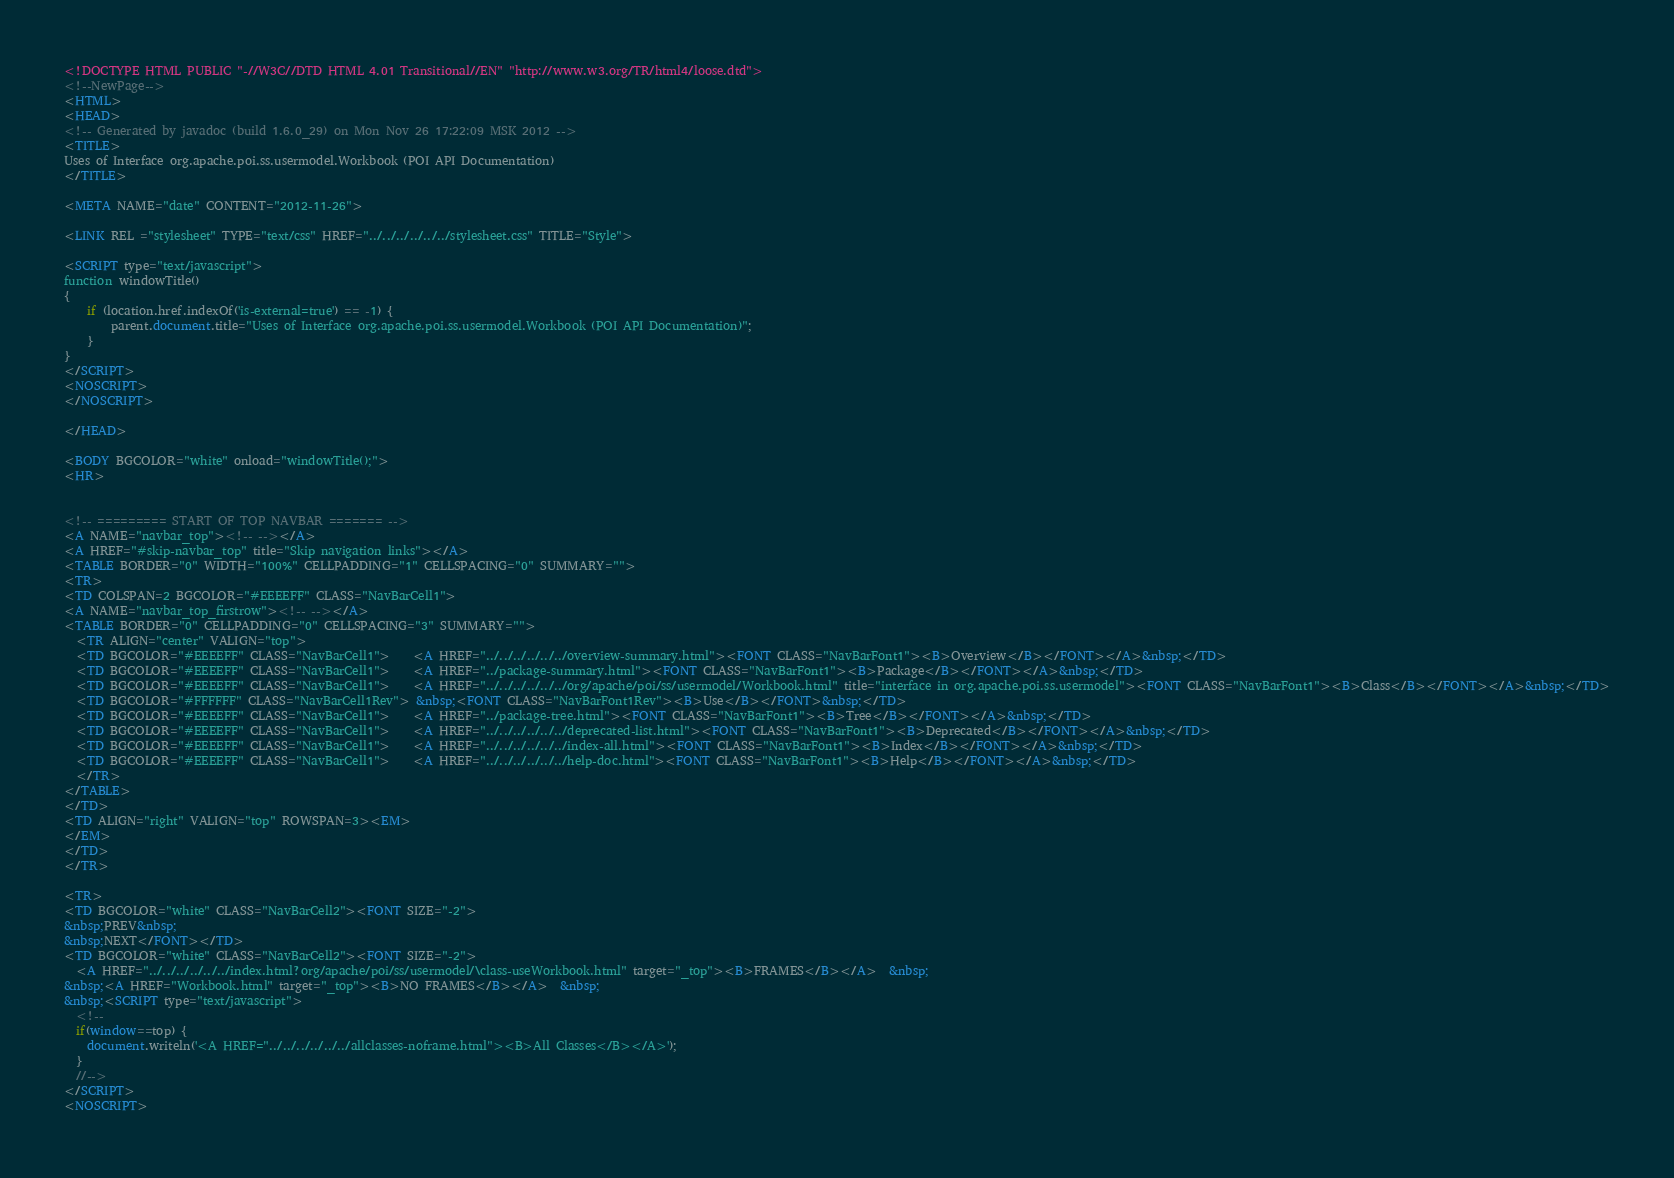Convert code to text. <code><loc_0><loc_0><loc_500><loc_500><_HTML_><!DOCTYPE HTML PUBLIC "-//W3C//DTD HTML 4.01 Transitional//EN" "http://www.w3.org/TR/html4/loose.dtd">
<!--NewPage-->
<HTML>
<HEAD>
<!-- Generated by javadoc (build 1.6.0_29) on Mon Nov 26 17:22:09 MSK 2012 -->
<TITLE>
Uses of Interface org.apache.poi.ss.usermodel.Workbook (POI API Documentation)
</TITLE>

<META NAME="date" CONTENT="2012-11-26">

<LINK REL ="stylesheet" TYPE="text/css" HREF="../../../../../../stylesheet.css" TITLE="Style">

<SCRIPT type="text/javascript">
function windowTitle()
{
    if (location.href.indexOf('is-external=true') == -1) {
        parent.document.title="Uses of Interface org.apache.poi.ss.usermodel.Workbook (POI API Documentation)";
    }
}
</SCRIPT>
<NOSCRIPT>
</NOSCRIPT>

</HEAD>

<BODY BGCOLOR="white" onload="windowTitle();">
<HR>


<!-- ========= START OF TOP NAVBAR ======= -->
<A NAME="navbar_top"><!-- --></A>
<A HREF="#skip-navbar_top" title="Skip navigation links"></A>
<TABLE BORDER="0" WIDTH="100%" CELLPADDING="1" CELLSPACING="0" SUMMARY="">
<TR>
<TD COLSPAN=2 BGCOLOR="#EEEEFF" CLASS="NavBarCell1">
<A NAME="navbar_top_firstrow"><!-- --></A>
<TABLE BORDER="0" CELLPADDING="0" CELLSPACING="3" SUMMARY="">
  <TR ALIGN="center" VALIGN="top">
  <TD BGCOLOR="#EEEEFF" CLASS="NavBarCell1">    <A HREF="../../../../../../overview-summary.html"><FONT CLASS="NavBarFont1"><B>Overview</B></FONT></A>&nbsp;</TD>
  <TD BGCOLOR="#EEEEFF" CLASS="NavBarCell1">    <A HREF="../package-summary.html"><FONT CLASS="NavBarFont1"><B>Package</B></FONT></A>&nbsp;</TD>
  <TD BGCOLOR="#EEEEFF" CLASS="NavBarCell1">    <A HREF="../../../../../../org/apache/poi/ss/usermodel/Workbook.html" title="interface in org.apache.poi.ss.usermodel"><FONT CLASS="NavBarFont1"><B>Class</B></FONT></A>&nbsp;</TD>
  <TD BGCOLOR="#FFFFFF" CLASS="NavBarCell1Rev"> &nbsp;<FONT CLASS="NavBarFont1Rev"><B>Use</B></FONT>&nbsp;</TD>
  <TD BGCOLOR="#EEEEFF" CLASS="NavBarCell1">    <A HREF="../package-tree.html"><FONT CLASS="NavBarFont1"><B>Tree</B></FONT></A>&nbsp;</TD>
  <TD BGCOLOR="#EEEEFF" CLASS="NavBarCell1">    <A HREF="../../../../../../deprecated-list.html"><FONT CLASS="NavBarFont1"><B>Deprecated</B></FONT></A>&nbsp;</TD>
  <TD BGCOLOR="#EEEEFF" CLASS="NavBarCell1">    <A HREF="../../../../../../index-all.html"><FONT CLASS="NavBarFont1"><B>Index</B></FONT></A>&nbsp;</TD>
  <TD BGCOLOR="#EEEEFF" CLASS="NavBarCell1">    <A HREF="../../../../../../help-doc.html"><FONT CLASS="NavBarFont1"><B>Help</B></FONT></A>&nbsp;</TD>
  </TR>
</TABLE>
</TD>
<TD ALIGN="right" VALIGN="top" ROWSPAN=3><EM>
</EM>
</TD>
</TR>

<TR>
<TD BGCOLOR="white" CLASS="NavBarCell2"><FONT SIZE="-2">
&nbsp;PREV&nbsp;
&nbsp;NEXT</FONT></TD>
<TD BGCOLOR="white" CLASS="NavBarCell2"><FONT SIZE="-2">
  <A HREF="../../../../../../index.html?org/apache/poi/ss/usermodel/\class-useWorkbook.html" target="_top"><B>FRAMES</B></A>  &nbsp;
&nbsp;<A HREF="Workbook.html" target="_top"><B>NO FRAMES</B></A>  &nbsp;
&nbsp;<SCRIPT type="text/javascript">
  <!--
  if(window==top) {
    document.writeln('<A HREF="../../../../../../allclasses-noframe.html"><B>All Classes</B></A>');
  }
  //-->
</SCRIPT>
<NOSCRIPT></code> 